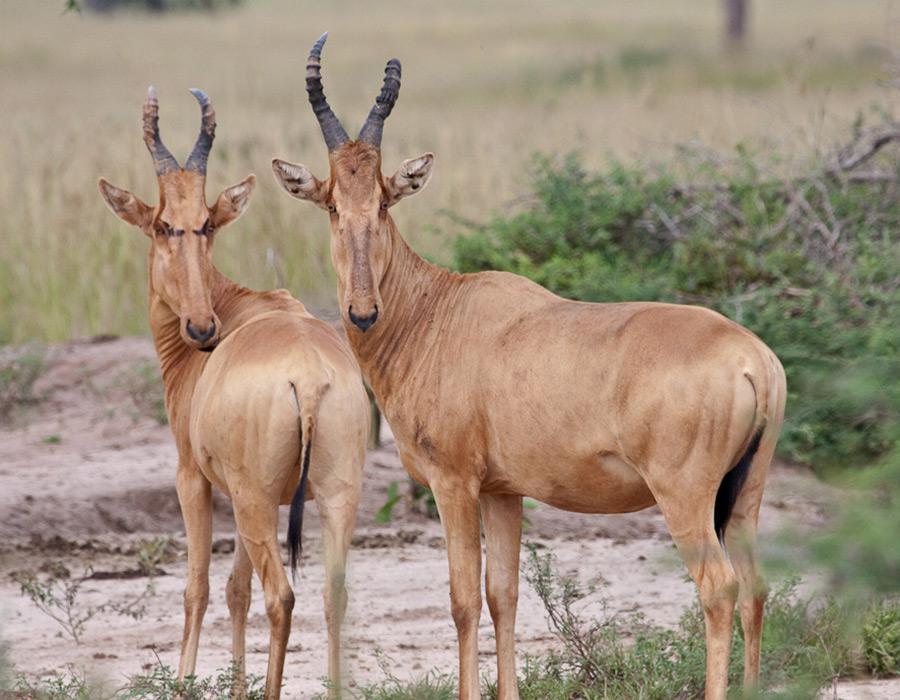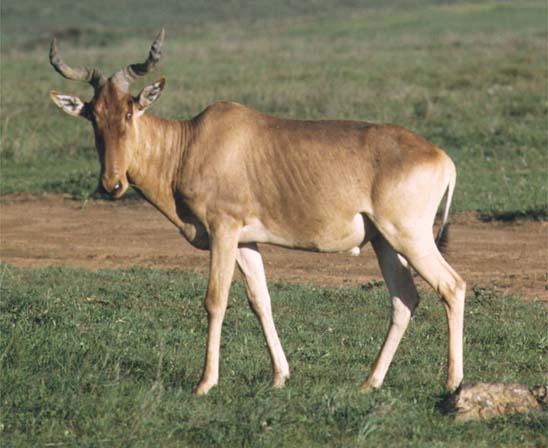The first image is the image on the left, the second image is the image on the right. Given the left and right images, does the statement "There are three animals." hold true? Answer yes or no. Yes. 